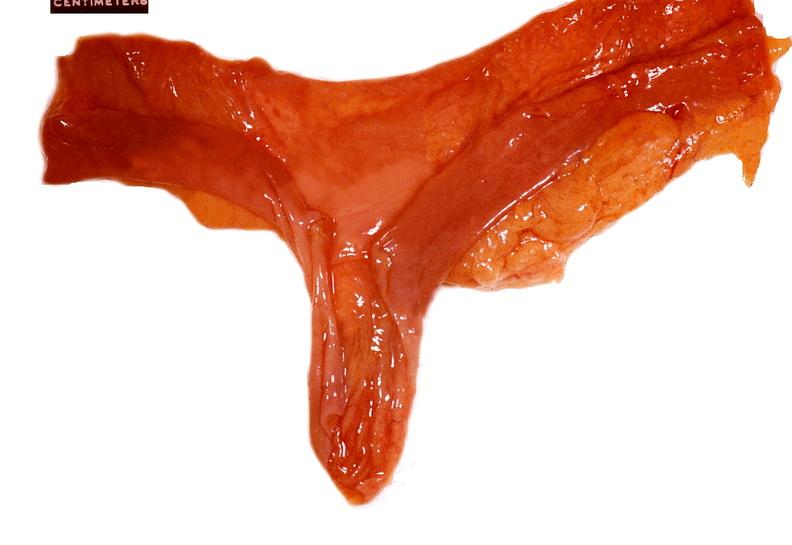where does this belong to?
Answer the question using a single word or phrase. Gastrointestinal system 